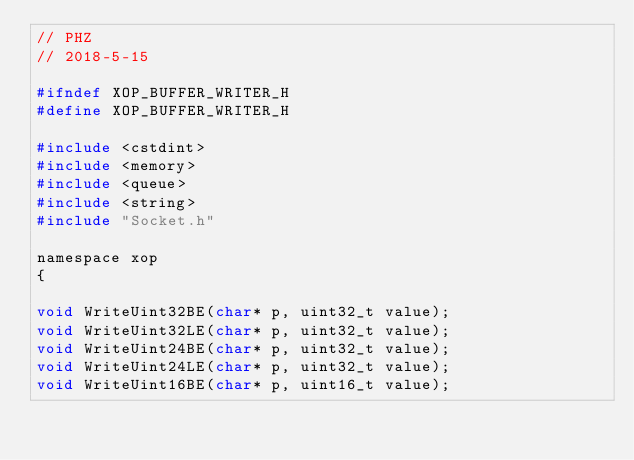<code> <loc_0><loc_0><loc_500><loc_500><_C_>// PHZ
// 2018-5-15

#ifndef XOP_BUFFER_WRITER_H
#define XOP_BUFFER_WRITER_H

#include <cstdint>
#include <memory>
#include <queue>
#include <string>
#include "Socket.h"

namespace xop
{

void WriteUint32BE(char* p, uint32_t value);
void WriteUint32LE(char* p, uint32_t value);
void WriteUint24BE(char* p, uint32_t value);
void WriteUint24LE(char* p, uint32_t value);
void WriteUint16BE(char* p, uint16_t value);</code> 